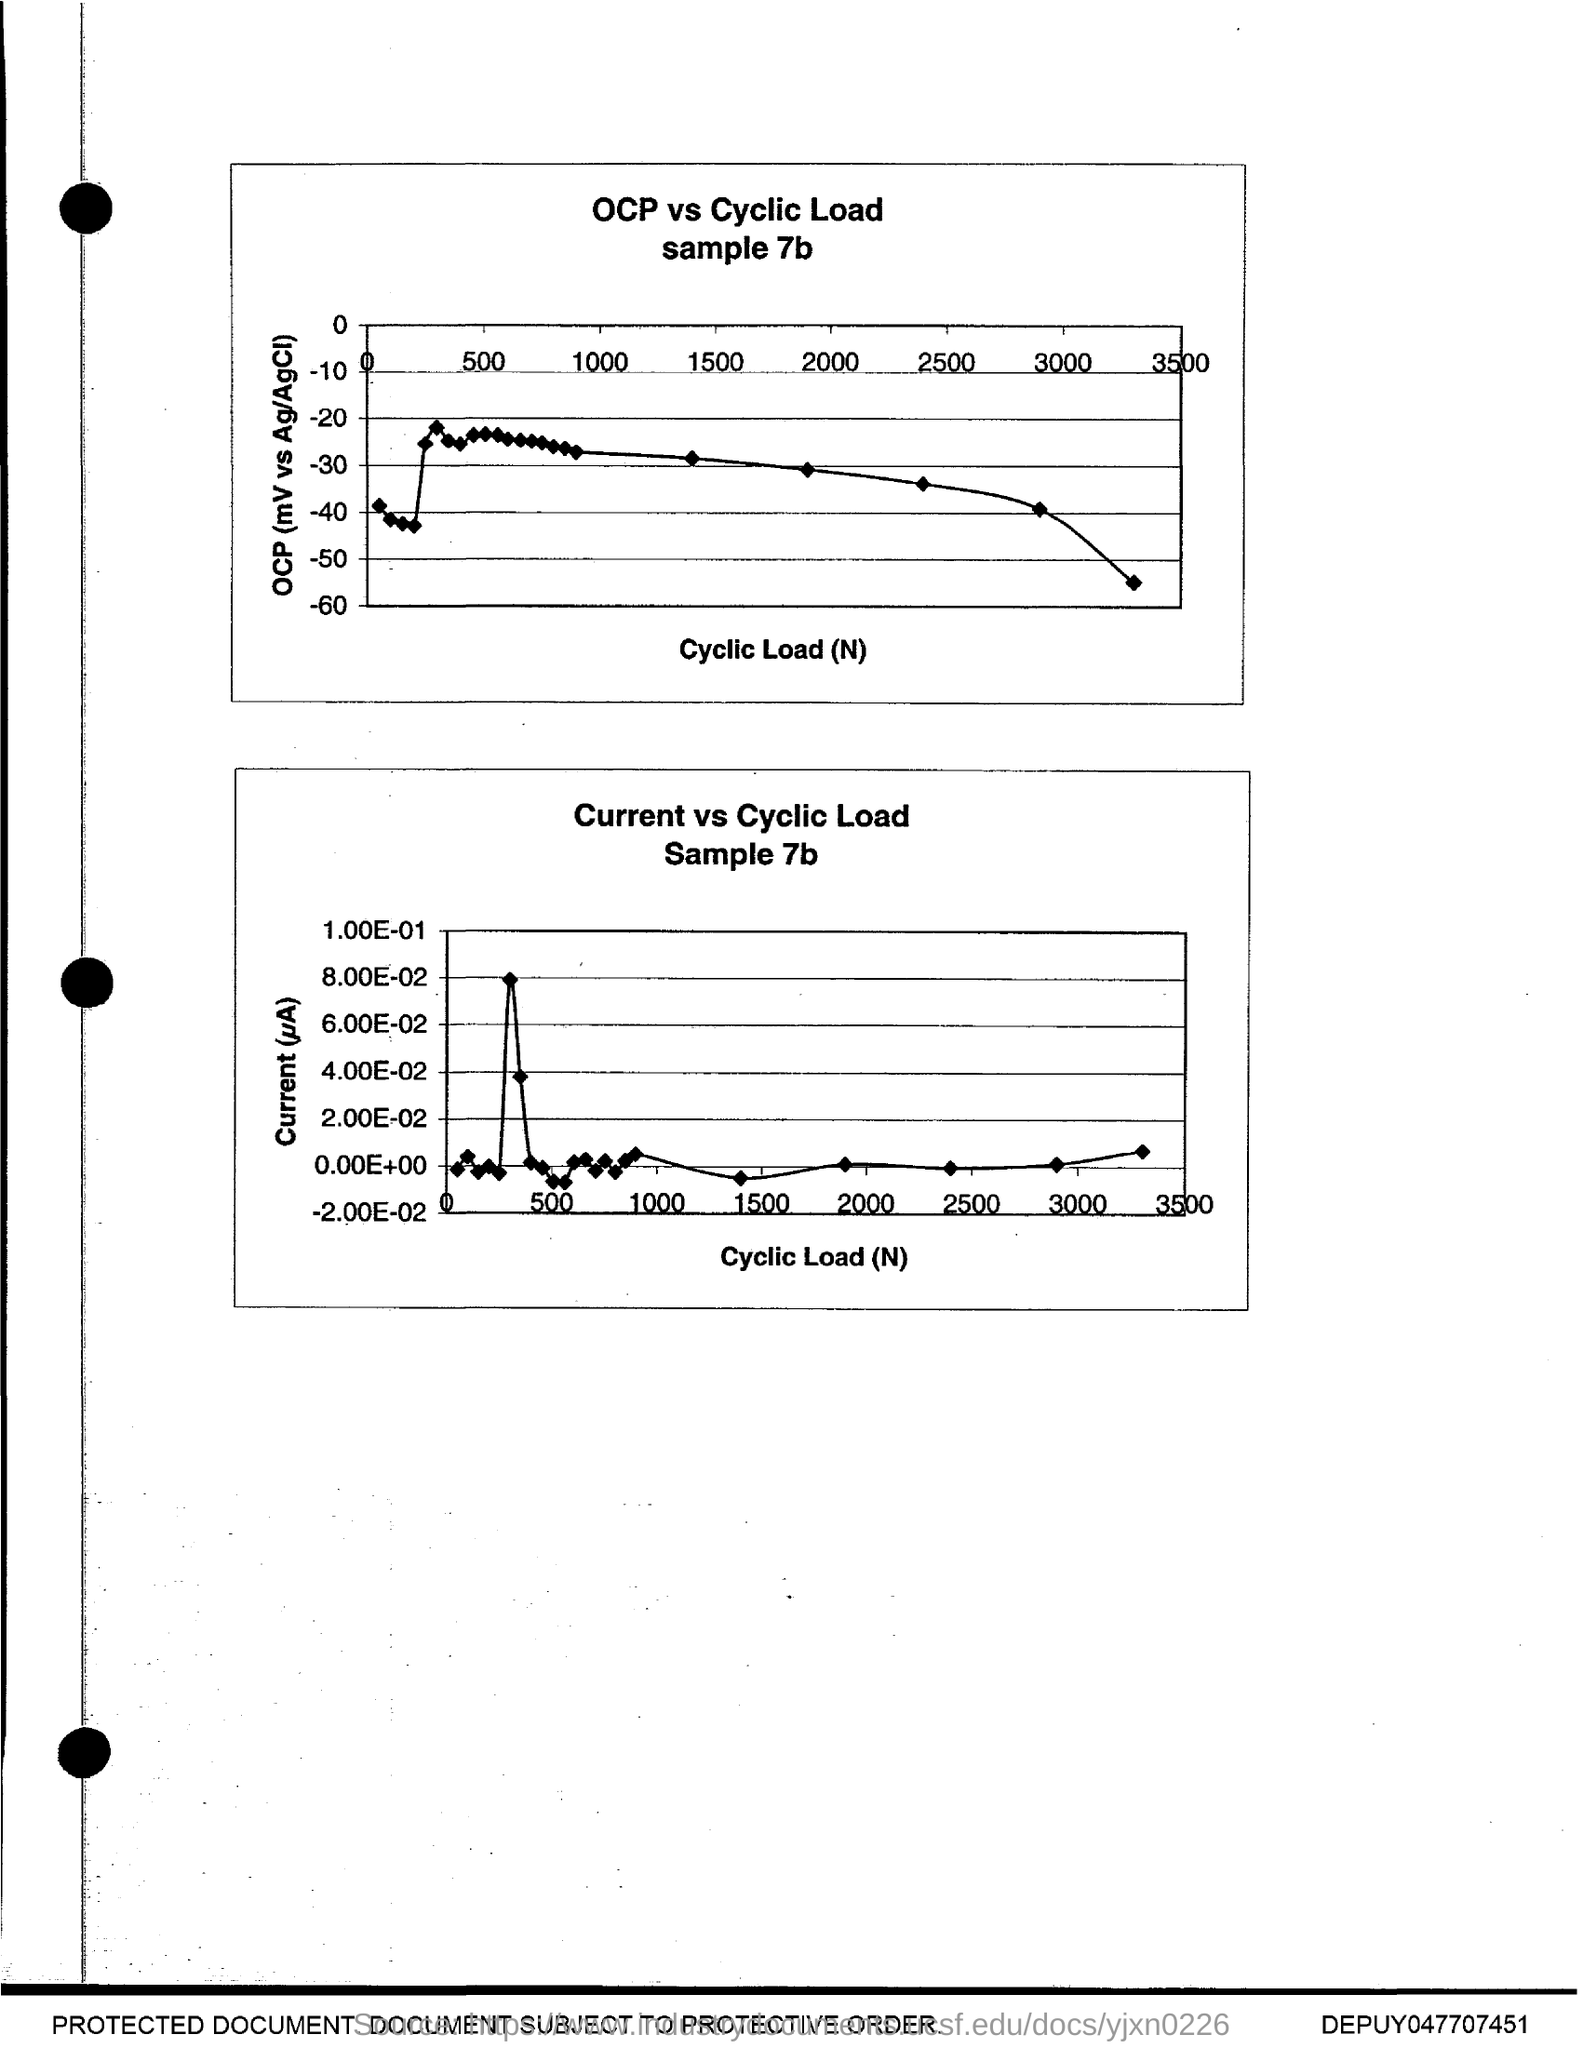Indicate a few pertinent items in this graphic. The x-axis of both graphs plots cyclic load (N). 